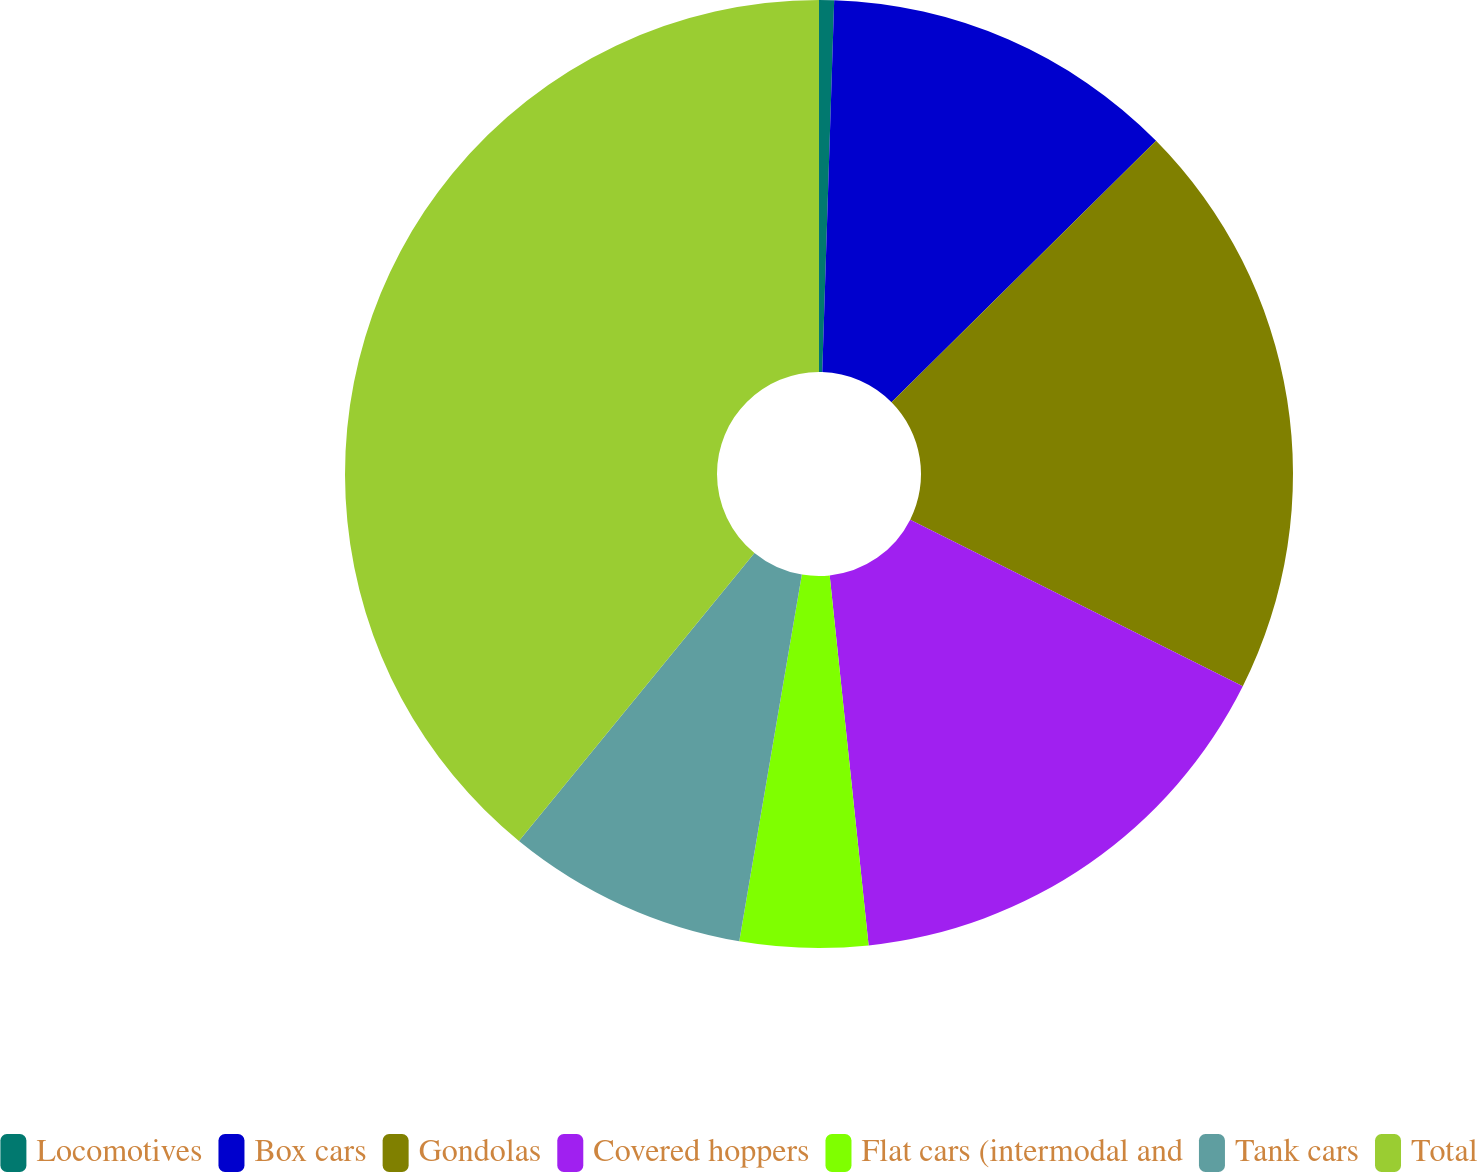Convert chart to OTSL. <chart><loc_0><loc_0><loc_500><loc_500><pie_chart><fcel>Locomotives<fcel>Box cars<fcel>Gondolas<fcel>Covered hoppers<fcel>Flat cars (intermodal and<fcel>Tank cars<fcel>Total<nl><fcel>0.51%<fcel>12.08%<fcel>19.8%<fcel>15.94%<fcel>4.36%<fcel>8.22%<fcel>39.09%<nl></chart> 